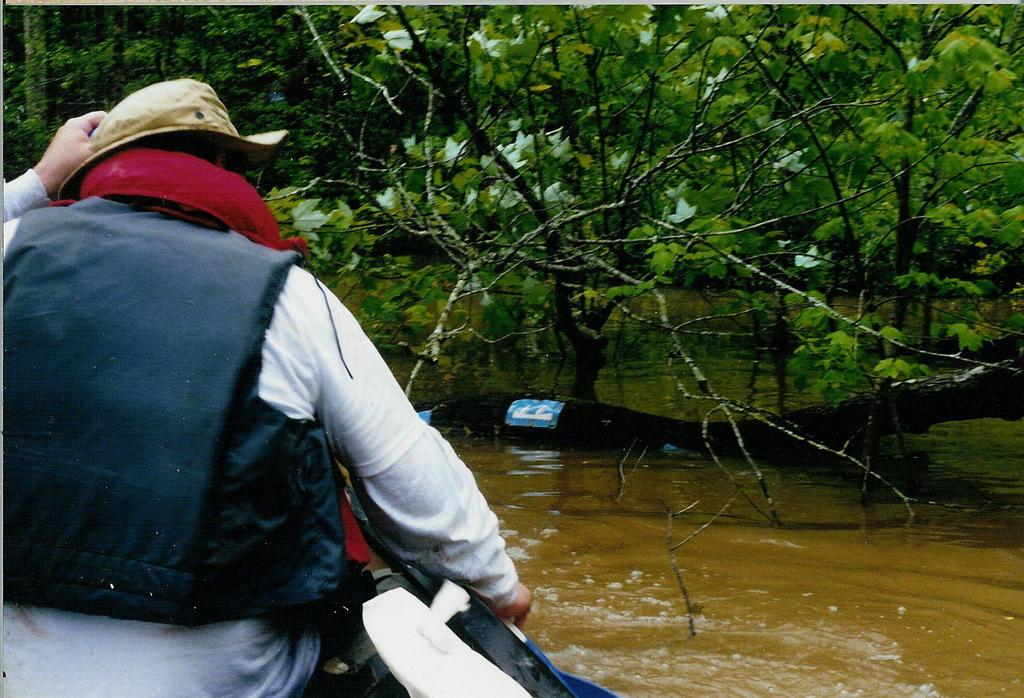What is the person in the image doing? The person is sitting on a boat in the image. Where is the boat located? The boat is on the water. What is the person wearing? The person is wearing a hat. What can be seen in the background of the image? There are trees in the background of the image. What type of industry is present on the island in the image? There is no island present in the image, so it is not possible to determine if there is any industry on it. 